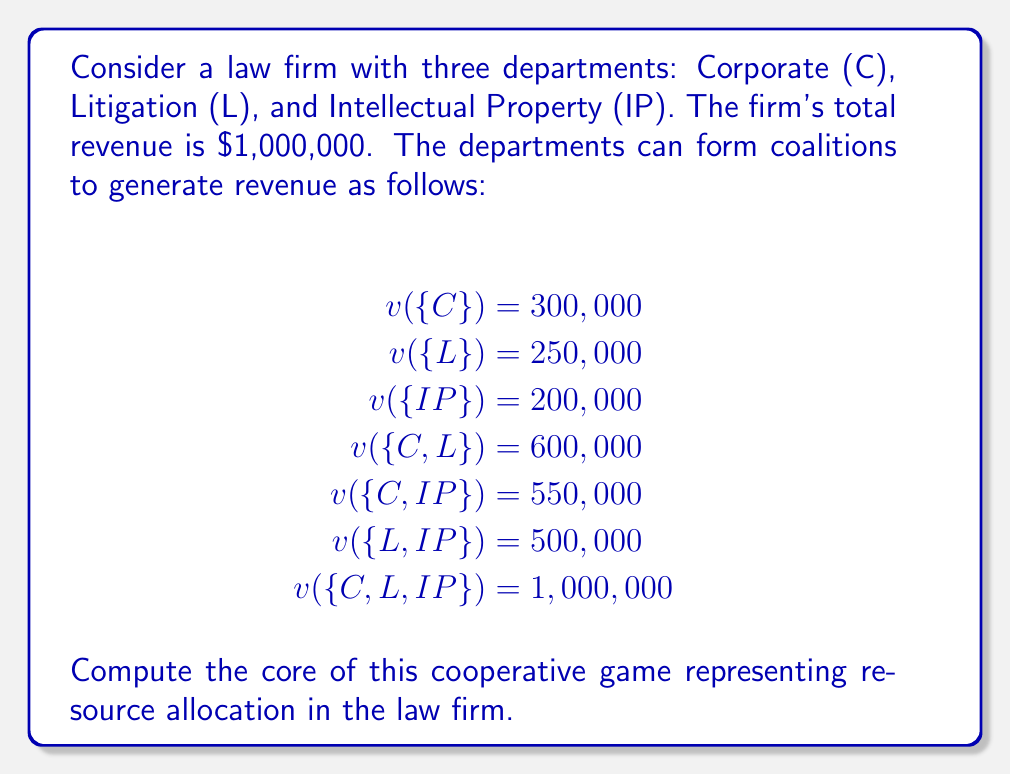Help me with this question. To compute the core of this cooperative game, we need to find all allocations $(x_C, x_L, x_{IP})$ that satisfy the following conditions:

1. Efficiency: The sum of all allocations must equal the grand coalition value.
   $x_C + x_L + x_{IP} = v(\{C,L,IP\}) = 1,000,000$

2. Individual rationality: Each department must receive at least as much as it can generate alone.
   $x_C \geq v(\{C\}) = 300,000$
   $x_L \geq v(\{L\}) = 250,000$
   $x_{IP} \geq v(\{IP\}) = 200,000$

3. Coalition rationality: No coalition should be able to improve by breaking away.
   $x_C + x_L \geq v(\{C,L\}) = 600,000$
   $x_C + x_{IP} \geq v(\{C,IP\}) = 550,000$
   $x_L + x_{IP} \geq v(\{L,IP\}) = 500,000$

These conditions define a system of linear inequalities. The core is the set of all allocations $(x_C, x_L, x_{IP})$ that satisfy these inequalities.

To find the extreme points of the core, we can solve the system of equations formed by taking three of the inequalities as equalities. The extreme points are:

1. $(450,000, 350,000, 200,000)$
2. $(450,000, 250,000, 300,000)$
3. $(400,000, 350,000, 250,000)$
4. $(500,000, 300,000, 200,000)$

The core is the convex hull of these extreme points, which means it includes all convex combinations of these points.
Answer: The core of the cooperative game is the convex hull of the following extreme points:

$$(450,000, 350,000, 200,000)$$
$$(450,000, 250,000, 300,000)$$
$$(400,000, 350,000, 250,000)$$
$$(500,000, 300,000, 200,000)$$

This represents all possible stable allocations of the firm's revenue among the three departments. 